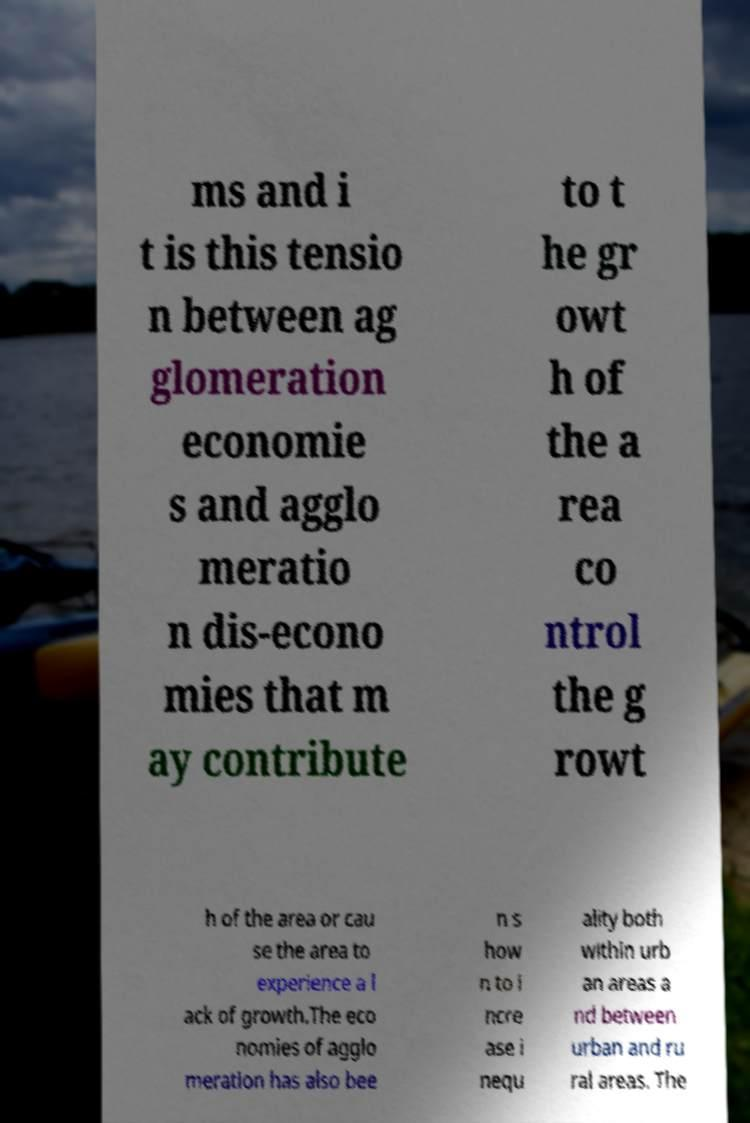There's text embedded in this image that I need extracted. Can you transcribe it verbatim? ms and i t is this tensio n between ag glomeration economie s and agglo meratio n dis-econo mies that m ay contribute to t he gr owt h of the a rea co ntrol the g rowt h of the area or cau se the area to experience a l ack of growth.The eco nomies of agglo meration has also bee n s how n to i ncre ase i nequ ality both within urb an areas a nd between urban and ru ral areas. The 